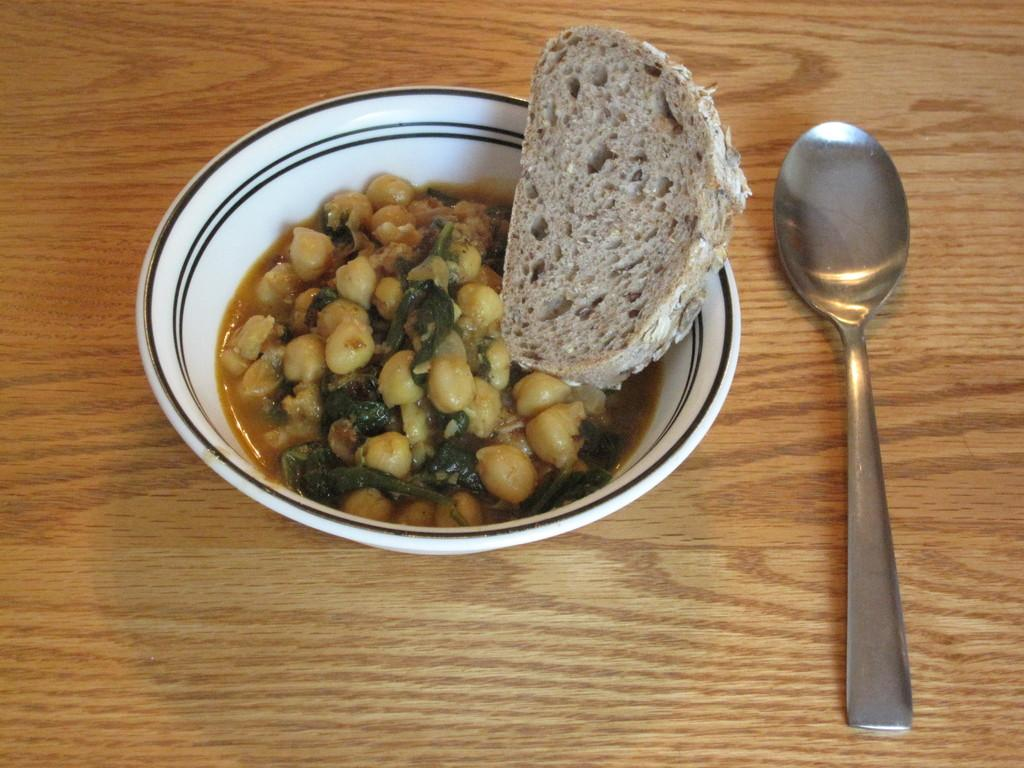What type of food is visible in the image? There is bread and a bowl with beans curry in the image. What color is the bowl containing the beans curry? The bowl is white. Where is the bowl with beans curry located? The bowl is on a table. What utensil is present in the image? There is a spoon on the right side of the image. What type of rock can be seen fueling the leaves in the image? There is no rock, fuel, or leaves present in the image. 